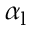<formula> <loc_0><loc_0><loc_500><loc_500>\alpha _ { l }</formula> 